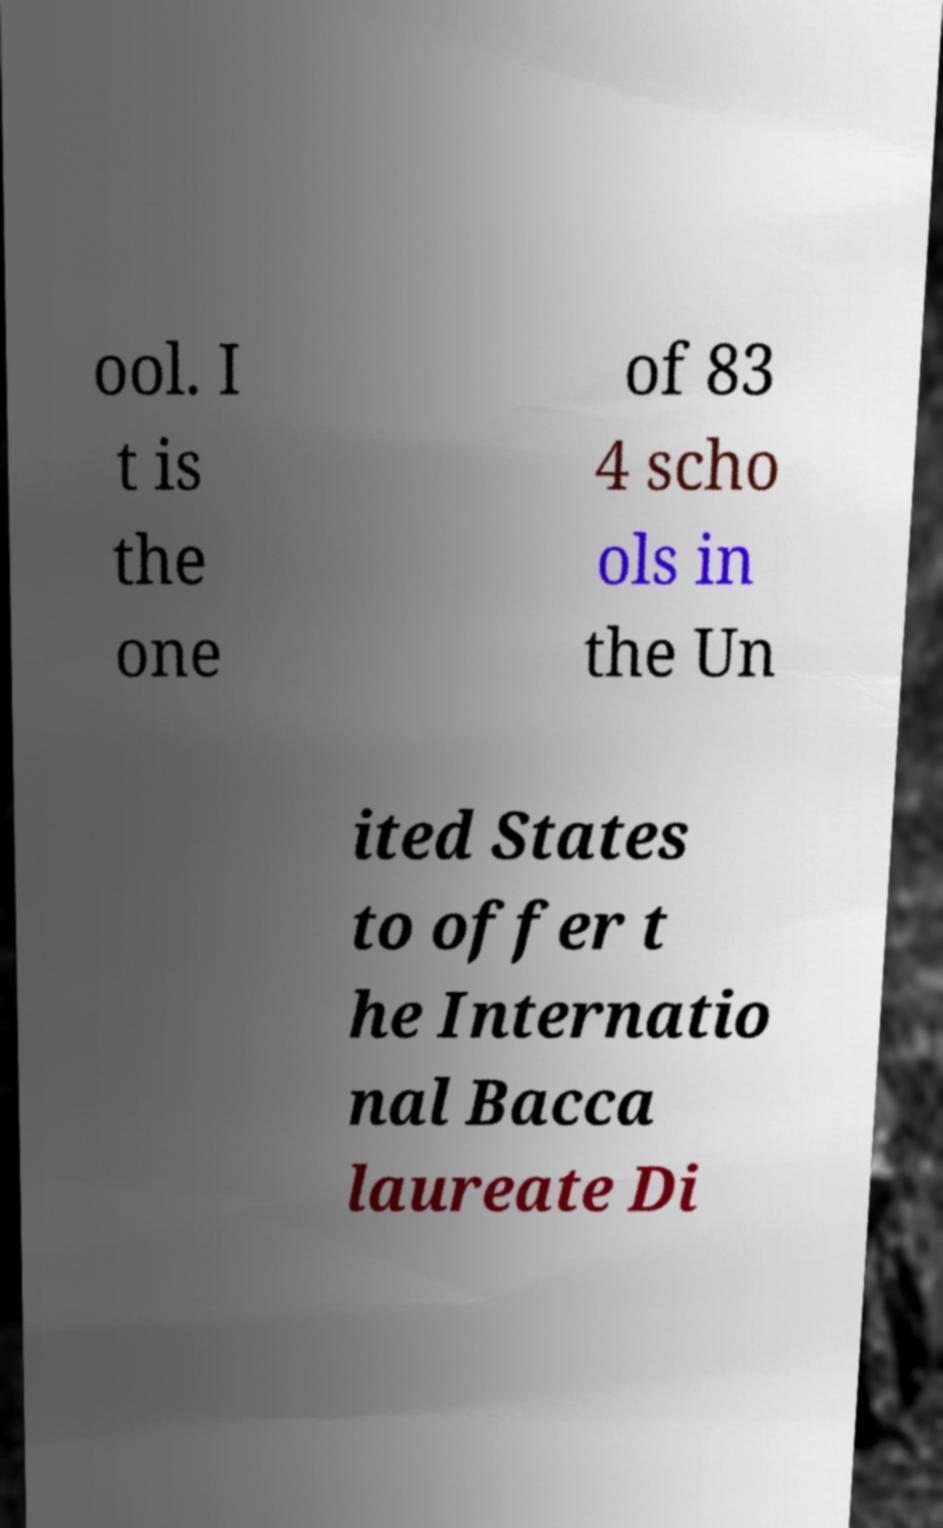Could you extract and type out the text from this image? ool. I t is the one of 83 4 scho ols in the Un ited States to offer t he Internatio nal Bacca laureate Di 